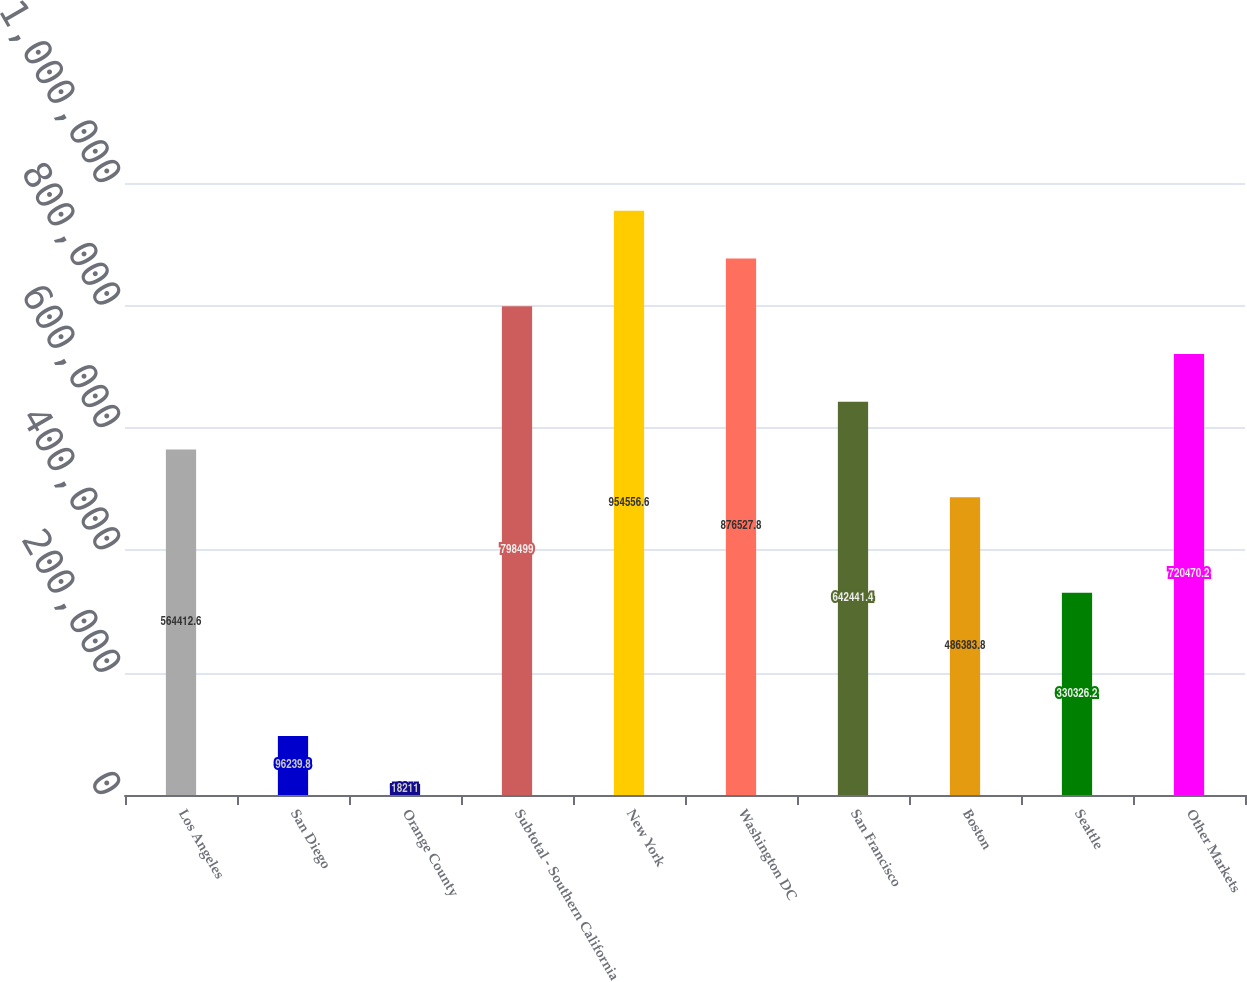Convert chart to OTSL. <chart><loc_0><loc_0><loc_500><loc_500><bar_chart><fcel>Los Angeles<fcel>San Diego<fcel>Orange County<fcel>Subtotal - Southern California<fcel>New York<fcel>Washington DC<fcel>San Francisco<fcel>Boston<fcel>Seattle<fcel>Other Markets<nl><fcel>564413<fcel>96239.8<fcel>18211<fcel>798499<fcel>954557<fcel>876528<fcel>642441<fcel>486384<fcel>330326<fcel>720470<nl></chart> 